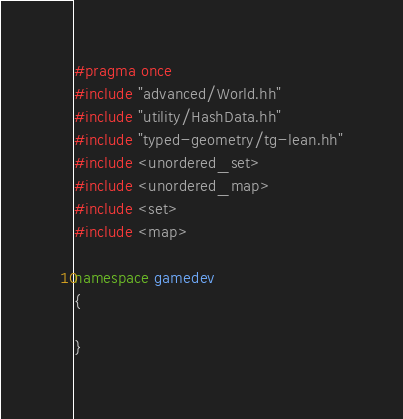<code> <loc_0><loc_0><loc_500><loc_500><_C++_>#pragma once
#include "advanced/World.hh"
#include "utility/HashData.hh"
#include "typed-geometry/tg-lean.hh"
#include <unordered_set>
#include <unordered_map>
#include <set>
#include <map>

namespace gamedev
{

}
</code> 